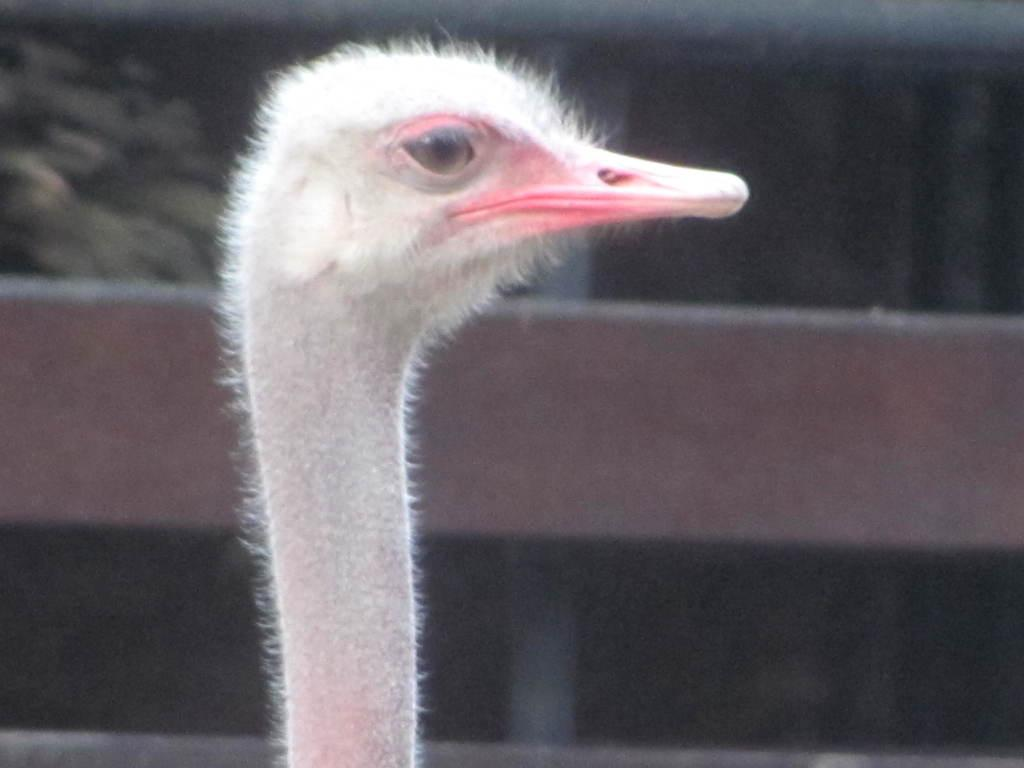What is the main subject of the image? There is an ostrich in the center of the image. What type of cable is being used by the ostrich to perform a balancing act in the image? There is no cable or balancing act present in the image; it features an ostrich standing in the center. How many rings can be seen on the ostrich's neck in the image? There are no rings visible on the ostrich's neck in the image. 